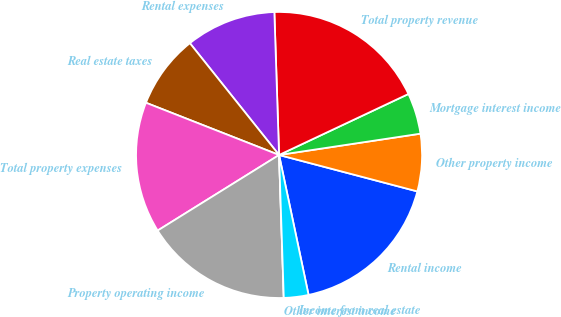<chart> <loc_0><loc_0><loc_500><loc_500><pie_chart><fcel>Rental income<fcel>Other property income<fcel>Mortgage interest income<fcel>Total property revenue<fcel>Rental expenses<fcel>Real estate taxes<fcel>Total property expenses<fcel>Property operating income<fcel>Other interest income<fcel>Income from real estate<nl><fcel>17.59%<fcel>6.48%<fcel>4.63%<fcel>18.51%<fcel>10.19%<fcel>8.33%<fcel>14.81%<fcel>16.66%<fcel>0.0%<fcel>2.78%<nl></chart> 